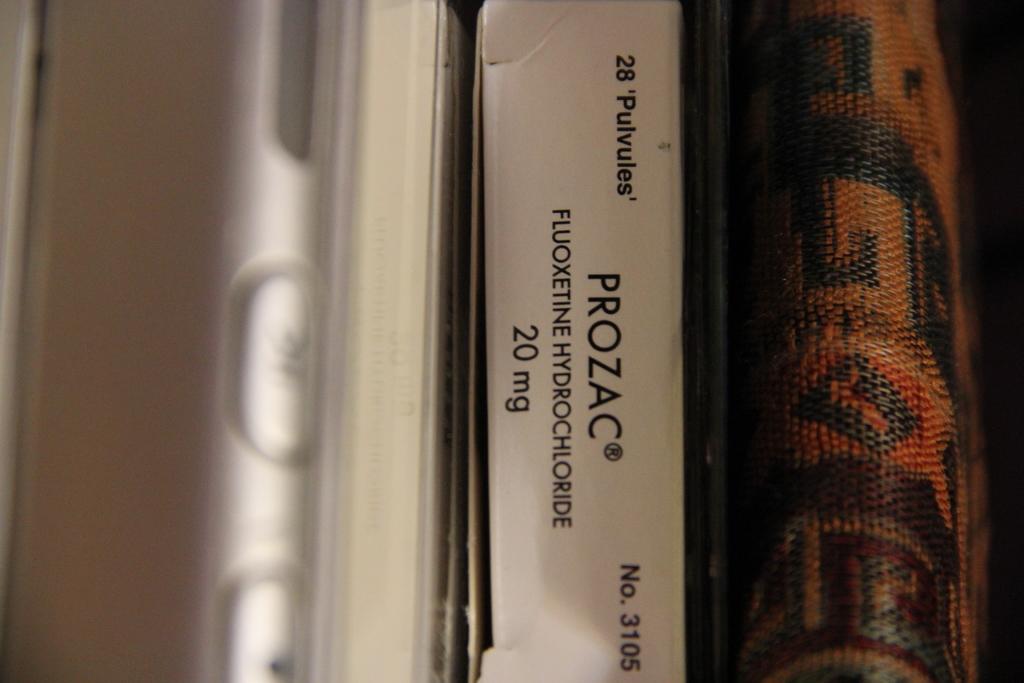What medication is in the box?
Your response must be concise. Prozac. What type of drug is in the box?
Offer a terse response. Prozac. 